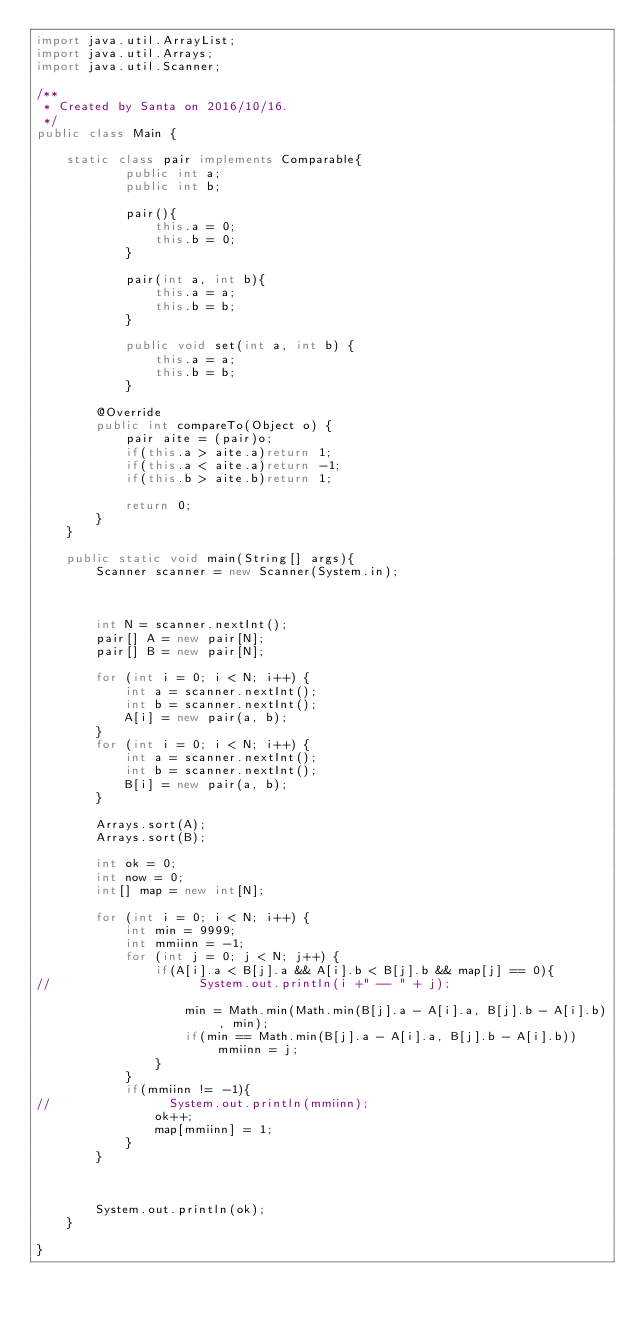<code> <loc_0><loc_0><loc_500><loc_500><_Java_>import java.util.ArrayList;
import java.util.Arrays;
import java.util.Scanner;

/**
 * Created by Santa on 2016/10/16.
 */
public class Main {

    static class pair implements Comparable{
            public int a;
            public int b;

            pair(){
                this.a = 0;
                this.b = 0;
            }

            pair(int a, int b){
                this.a = a;
                this.b = b;
            }

            public void set(int a, int b) {
                this.a = a;
                this.b = b;
            }

        @Override
        public int compareTo(Object o) {
            pair aite = (pair)o;
            if(this.a > aite.a)return 1;
            if(this.a < aite.a)return -1;
            if(this.b > aite.b)return 1;

            return 0;
        }
    }

    public static void main(String[] args){
        Scanner scanner = new Scanner(System.in);



        int N = scanner.nextInt();
        pair[] A = new pair[N];
        pair[] B = new pair[N];

        for (int i = 0; i < N; i++) {
            int a = scanner.nextInt();
            int b = scanner.nextInt();
            A[i] = new pair(a, b);
        }
        for (int i = 0; i < N; i++) {
            int a = scanner.nextInt();
            int b = scanner.nextInt();
            B[i] = new pair(a, b);
        }

        Arrays.sort(A);
        Arrays.sort(B);

        int ok = 0;
        int now = 0;
        int[] map = new int[N];

        for (int i = 0; i < N; i++) {
            int min = 9999;
            int mmiinn = -1;
            for (int j = 0; j < N; j++) {
                if(A[i].a < B[j].a && A[i].b < B[j].b && map[j] == 0){
//                    System.out.println(i +" -- " + j);

                    min = Math.min(Math.min(B[j].a - A[i].a, B[j].b - A[i].b), min);
                    if(min == Math.min(B[j].a - A[i].a, B[j].b - A[i].b))mmiinn = j;
                }
            }
            if(mmiinn != -1){
//                System.out.println(mmiinn);
                ok++;
                map[mmiinn] = 1;
            }
        }



        System.out.println(ok);
    }

}</code> 